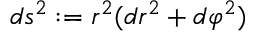<formula> <loc_0><loc_0><loc_500><loc_500>d s ^ { 2 } \colon = r ^ { 2 } ( d r ^ { 2 } + d \varphi ^ { 2 } )</formula> 